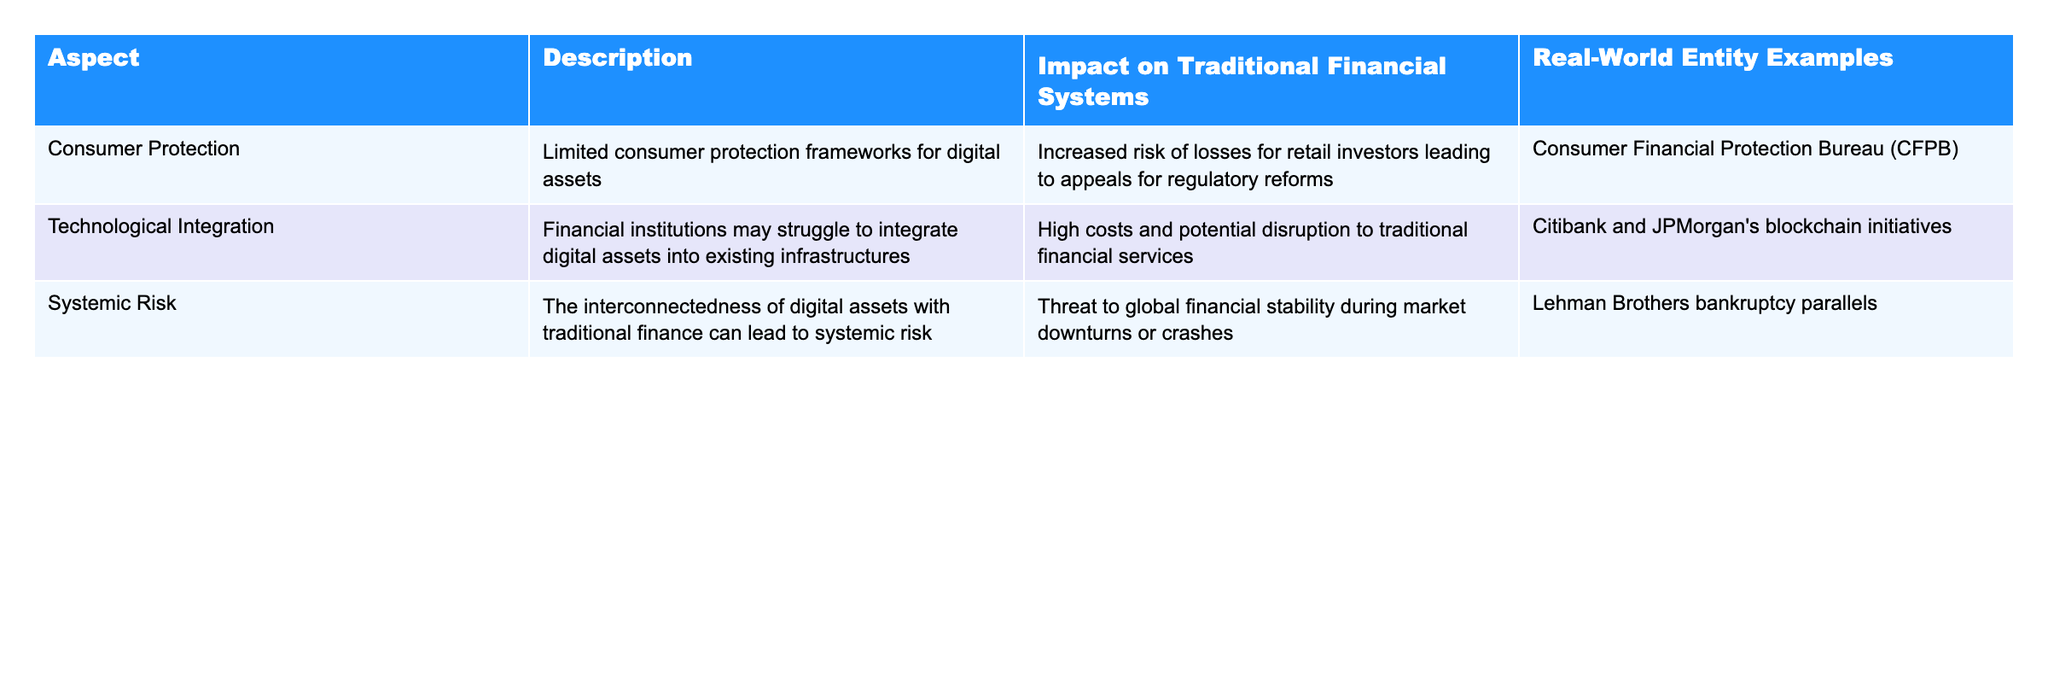What is the impact of limited consumer protection frameworks on retail investors? The table indicates that limited consumer protection frameworks for digital assets lead to increased risks of losses for retail investors. This highlights the necessity for regulatory reforms to protect these investors.
Answer: Increased risk of losses Which financial institution is indicated to be struggling with the integration of digital assets? Citibank and JPMorgan are mentioned as examples of financial institutions that may struggle with integrating digital assets into their existing infrastructures.
Answer: Citibank and JPMorgan What entity is referenced in relation to the systemic risk posed by the interconnectedness of digital assets with traditional finance? The table uses the Lehman Brothers bankruptcy as a real-world example, showing how interconnectedness can threaten global financial stability.
Answer: Lehman Brothers bankruptcy Are consumer protection frameworks sufficient for digital assets? The table implies that the current consumer protection frameworks for digital assets are limited, indicating they are not sufficient for protecting investors.
Answer: No What two aspects of unregulated digital assets potentially impact traditional financial systems the most? The table includes limited consumer protection and technological integration as significant aspects that could impact traditional financial systems. Both aspects pose risks to traditional practices.
Answer: Limited consumer protection and technological integration How does the lack of regulation in digital assets contribute to systemic risk in traditional finance? The table states that the interconnectedness of digital assets with traditional finance can lead to systemic risks, especially during market downturns or crashes, which can threaten global financial stability.
Answer: It leads to systemic risks during market downturns What is the potential effect of high costs associated with technological integration on traditional financial services? According to the table, high costs associated with integrating digital assets may disrupt traditional financial services, indicating a negative financial impact.
Answer: Potential disruption to services Which real-world entity example relates to consumer protection issues in digital assets? The consumer protection aspect refers to the Consumer Financial Protection Bureau (CFPB), which is mentioned as addressing the increased risks faced by retail investors in digital assets.
Answer: Consumer Financial Protection Bureau (CFPB) Considering the examples in the table, how might the interconnectedness of digital assets and traditional finance affect market stability during a crisis? The table suggests that the interconnectedness could lead to systemic risk, amplifying threats to global financial stability during market crises, as exemplified by the Lehman Brothers bankruptcy.
Answer: It can threaten market stability significantly 